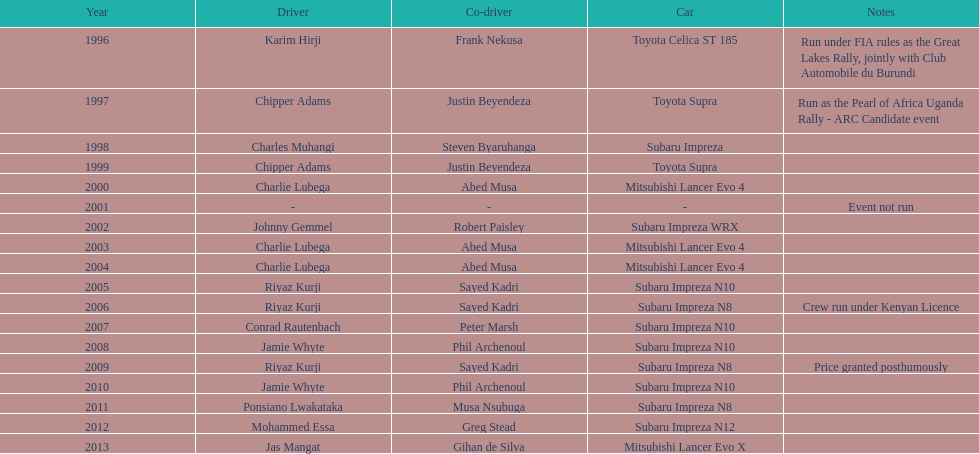What is the total number of wins for chipper adams and justin beyendeza? 2. 